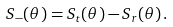<formula> <loc_0><loc_0><loc_500><loc_500>S _ { - } ( \theta ) = S _ { t } ( \theta ) - S _ { r } ( \theta ) \, .</formula> 